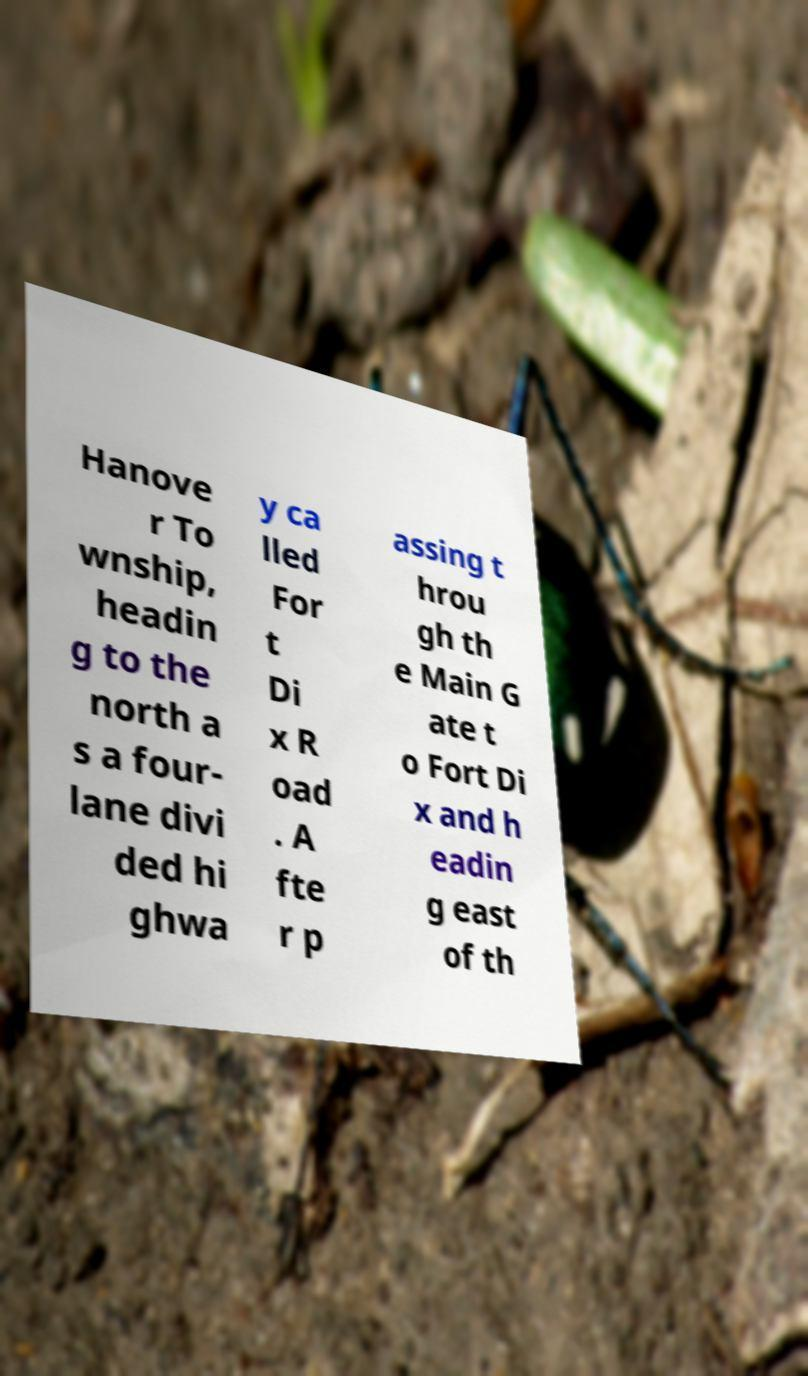I need the written content from this picture converted into text. Can you do that? Hanove r To wnship, headin g to the north a s a four- lane divi ded hi ghwa y ca lled For t Di x R oad . A fte r p assing t hrou gh th e Main G ate t o Fort Di x and h eadin g east of th 